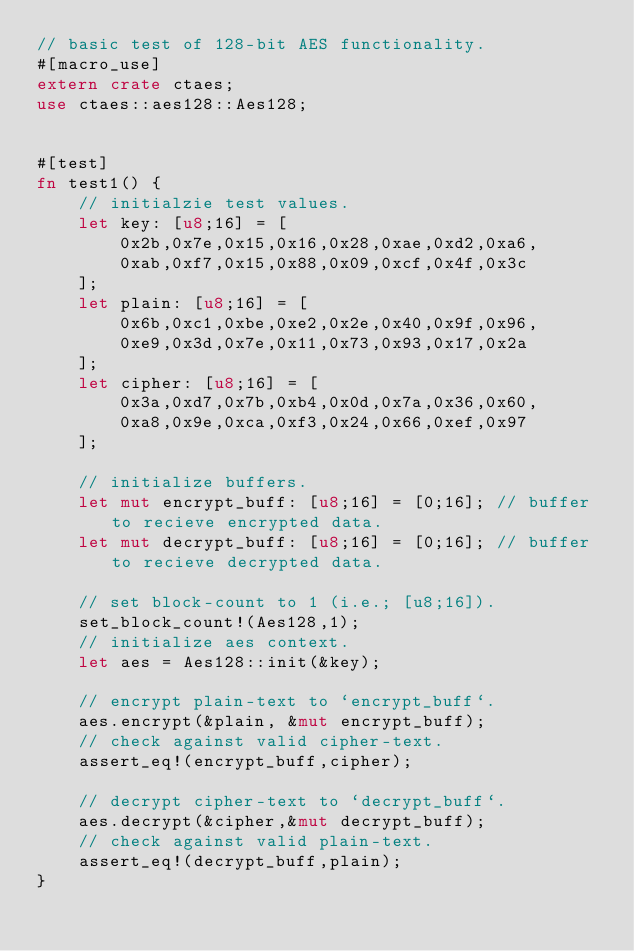<code> <loc_0><loc_0><loc_500><loc_500><_Rust_>// basic test of 128-bit AES functionality.
#[macro_use]
extern crate ctaes;
use ctaes::aes128::Aes128;


#[test]
fn test1() {
    // initialzie test values.
    let key: [u8;16] = [
        0x2b,0x7e,0x15,0x16,0x28,0xae,0xd2,0xa6,
        0xab,0xf7,0x15,0x88,0x09,0xcf,0x4f,0x3c
    ];
    let plain: [u8;16] = [
        0x6b,0xc1,0xbe,0xe2,0x2e,0x40,0x9f,0x96,
        0xe9,0x3d,0x7e,0x11,0x73,0x93,0x17,0x2a
    ];
    let cipher: [u8;16] = [
        0x3a,0xd7,0x7b,0xb4,0x0d,0x7a,0x36,0x60,
        0xa8,0x9e,0xca,0xf3,0x24,0x66,0xef,0x97
    ];

    // initialize buffers.
    let mut encrypt_buff: [u8;16] = [0;16]; // buffer to recieve encrypted data.
    let mut decrypt_buff: [u8;16] = [0;16]; // buffer to recieve decrypted data.

    // set block-count to 1 (i.e.; [u8;16]).
    set_block_count!(Aes128,1);
    // initialize aes context.
    let aes = Aes128::init(&key);

    // encrypt plain-text to `encrypt_buff`.
    aes.encrypt(&plain, &mut encrypt_buff);
    // check against valid cipher-text.
    assert_eq!(encrypt_buff,cipher);

    // decrypt cipher-text to `decrypt_buff`.
    aes.decrypt(&cipher,&mut decrypt_buff);
    // check against valid plain-text.
    assert_eq!(decrypt_buff,plain);
}
</code> 